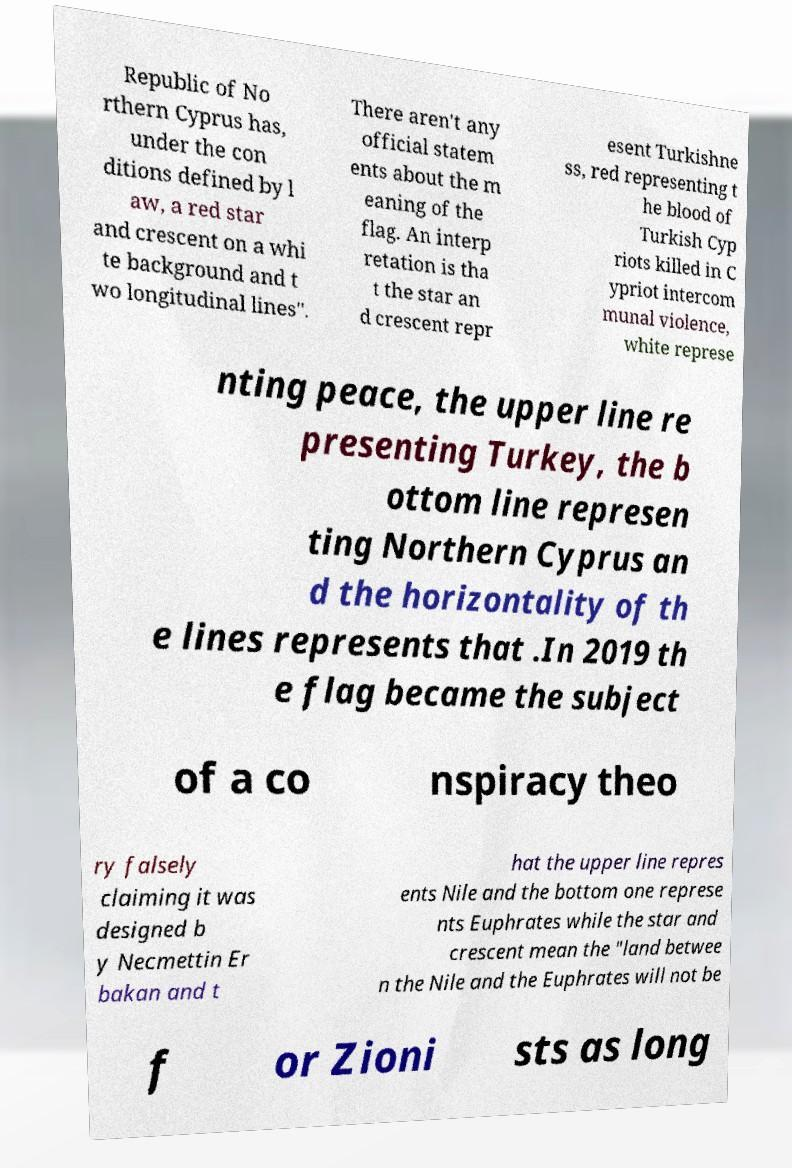Could you extract and type out the text from this image? Republic of No rthern Cyprus has, under the con ditions defined by l aw, a red star and crescent on a whi te background and t wo longitudinal lines". There aren't any official statem ents about the m eaning of the flag. An interp retation is tha t the star an d crescent repr esent Turkishne ss, red representing t he blood of Turkish Cyp riots killed in C ypriot intercom munal violence, white represe nting peace, the upper line re presenting Turkey, the b ottom line represen ting Northern Cyprus an d the horizontality of th e lines represents that .In 2019 th e flag became the subject of a co nspiracy theo ry falsely claiming it was designed b y Necmettin Er bakan and t hat the upper line repres ents Nile and the bottom one represe nts Euphrates while the star and crescent mean the "land betwee n the Nile and the Euphrates will not be f or Zioni sts as long 